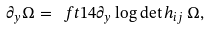<formula> <loc_0><loc_0><loc_500><loc_500>\partial _ { y } \Omega = \ f t 1 4 \partial _ { y } \log \det h _ { i j } \, \Omega ,</formula> 